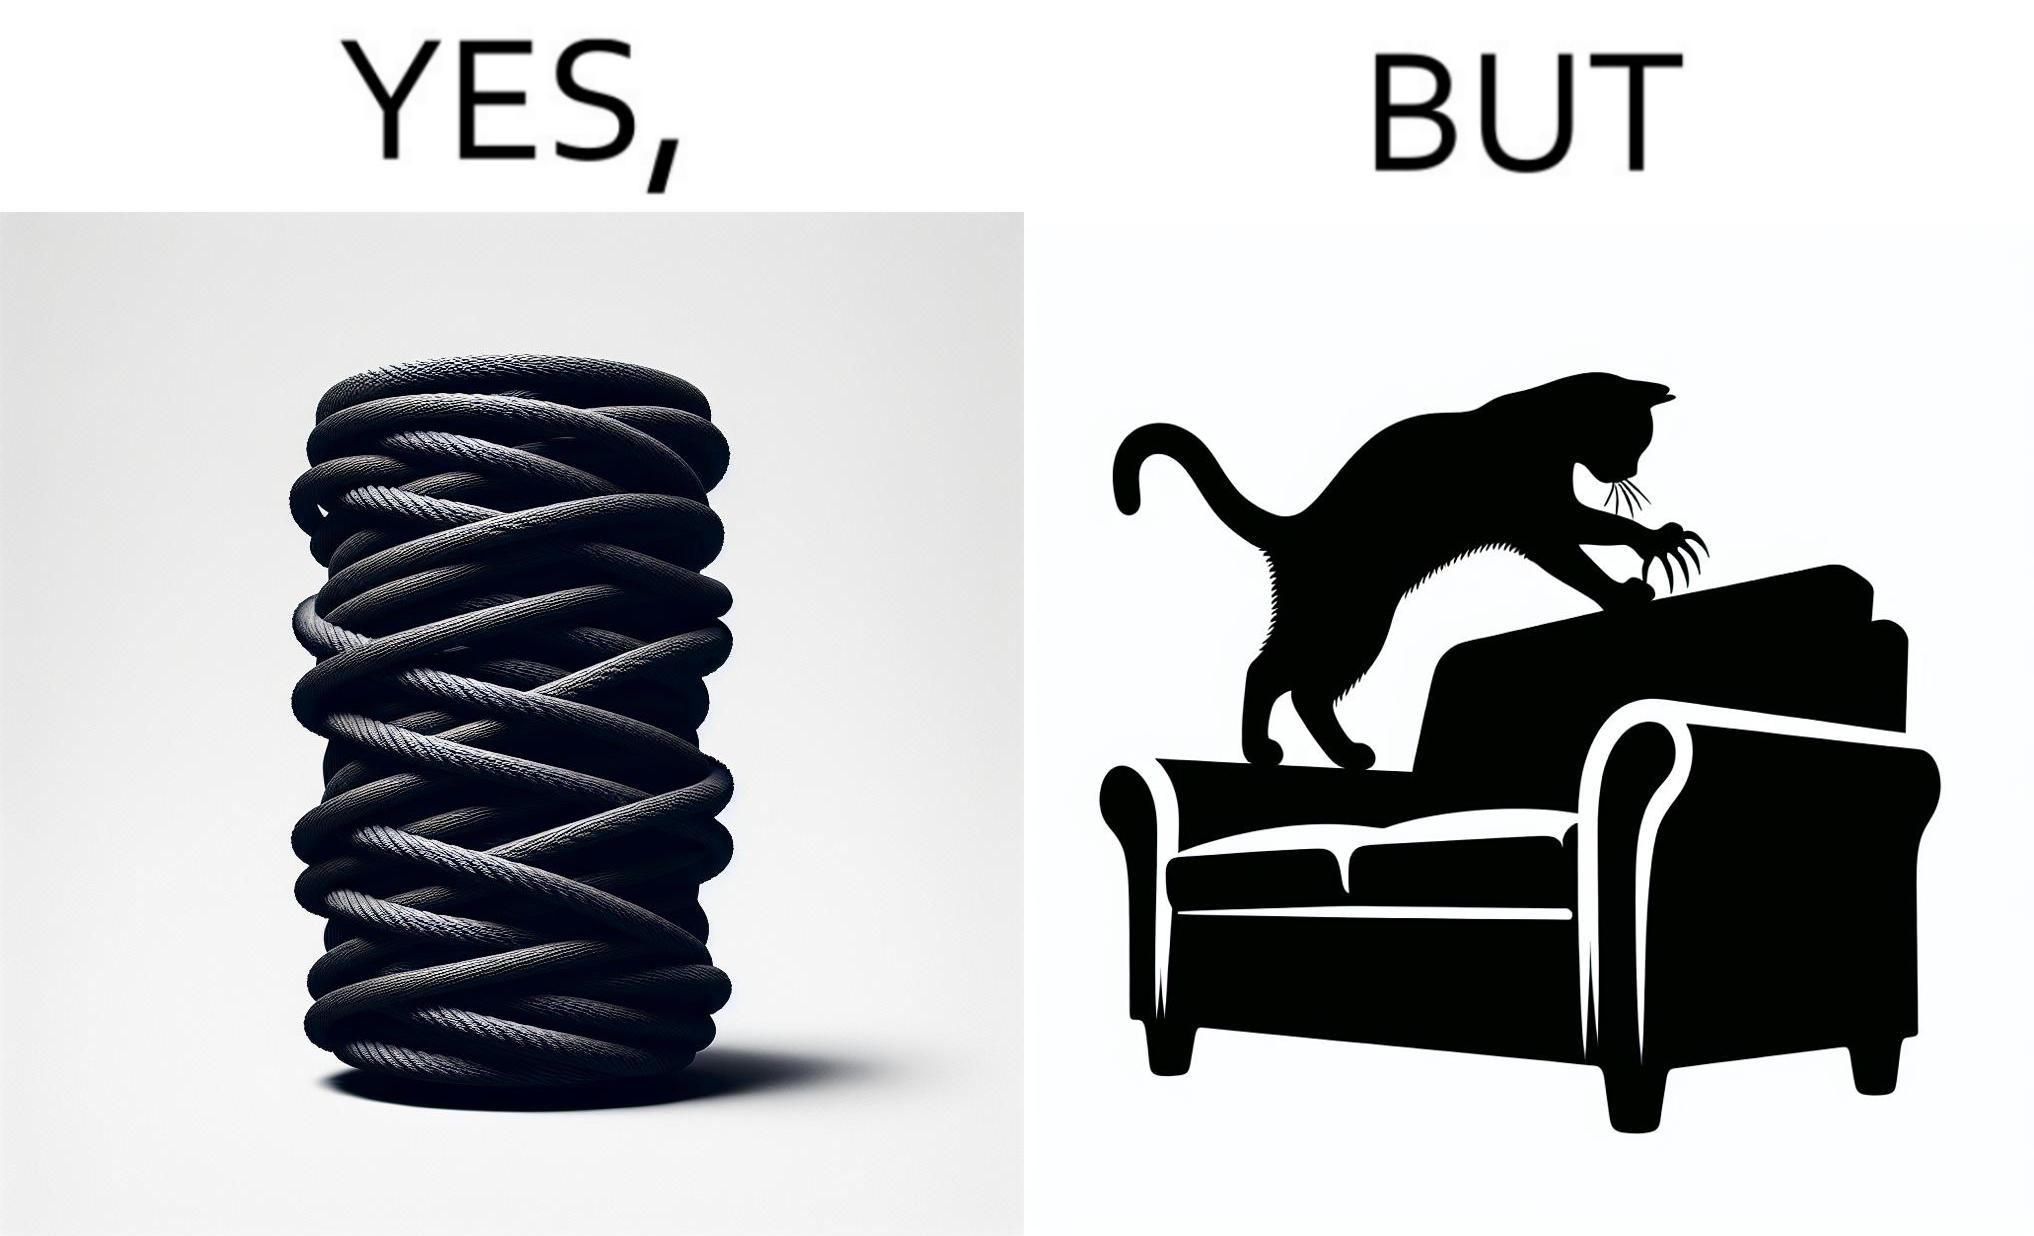What is the satirical meaning behind this image? The image is ironic, because in the first image a toy, purposed for the cat to play with is shown but in the second image the cat is comfortably enjoying  to play on the sides of sofa 